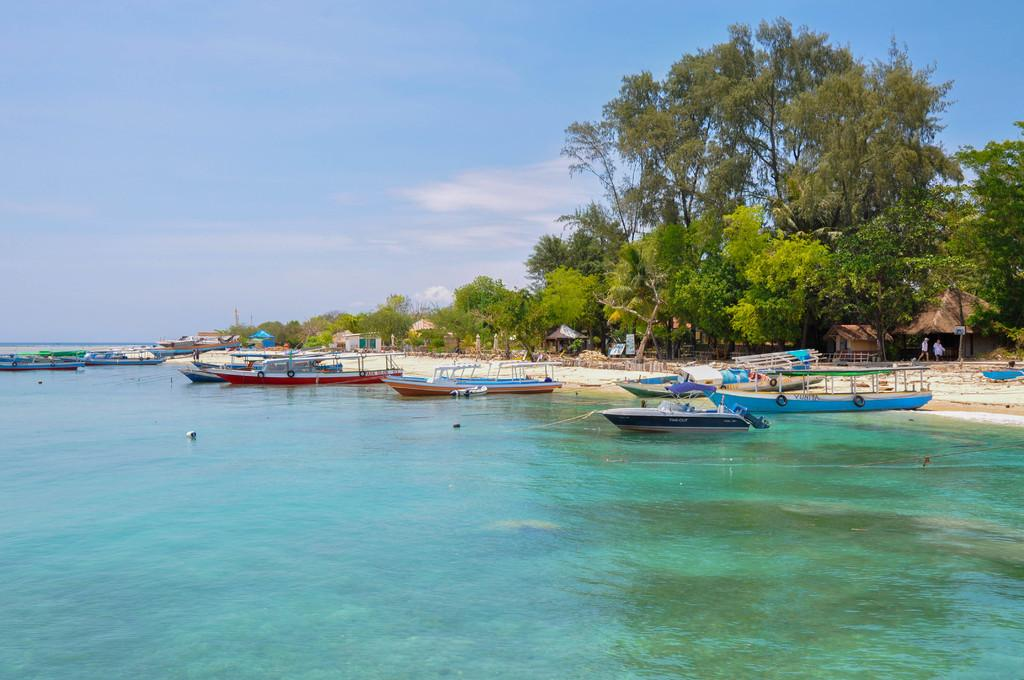What is on the water in the image? There are boats on the water in the image. What structure can be seen in the image? There is a fence in the image. What type of buildings are present in the image? There are huts in the image. What material is visible in the image? There are boards in the image. Who or what is present in the image? There are people in the image. What type of vegetation is in the image? There are trees in the image. What can be seen in the background of the image? The sky with clouds is visible in the background of the image. What color is the crayon used to draw the list in the image? There is no crayon or list present in the image. Why are the people in the image crying? There is no indication in the image that the people are crying. 